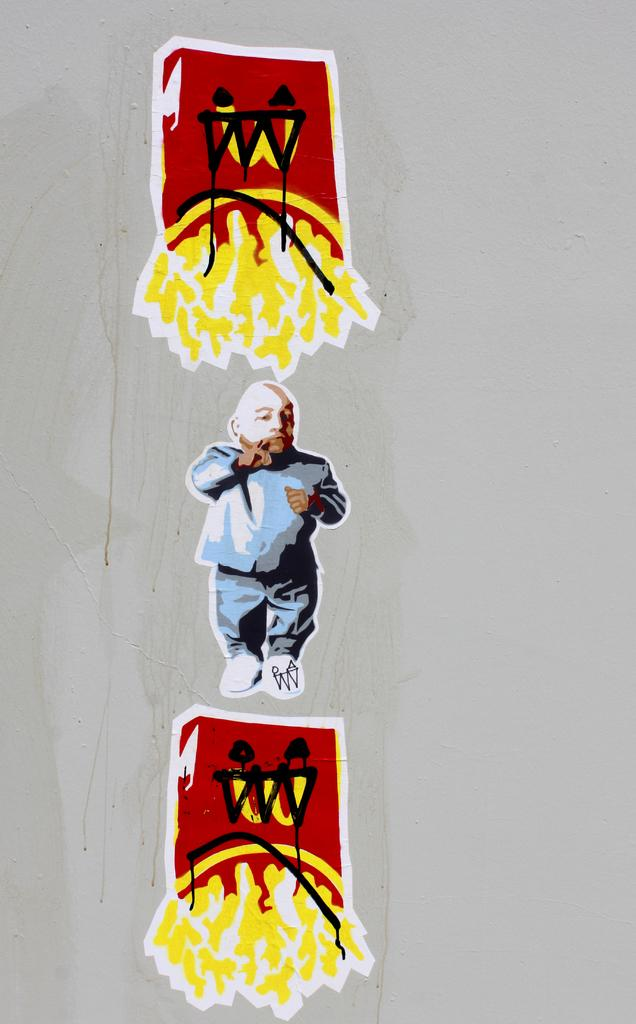What is the main subject of the image? There is a painting in the image. What does the painting depict? The painting depicts a person. Are there any other elements in the painting besides the person? Yes, there are other objects in the painting. Where is the painting located in the image? The painting is on a wall. Can you hear the whistle being blown by the person in the painting? There is no sound in the image, and the painting does not depict a person blowing a whistle. 